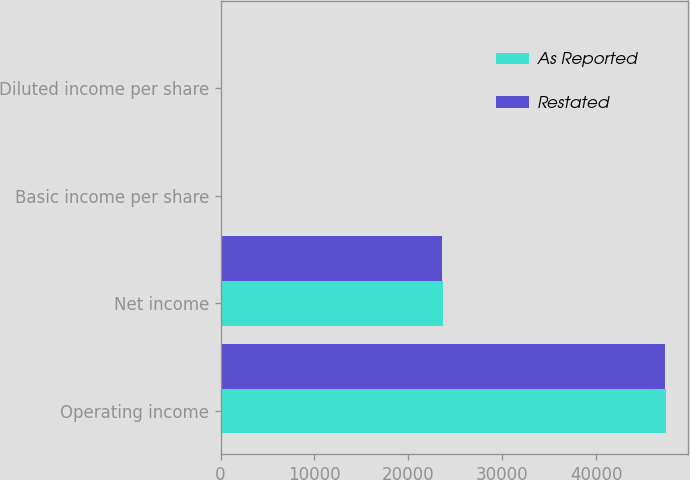<chart> <loc_0><loc_0><loc_500><loc_500><stacked_bar_chart><ecel><fcel>Operating income<fcel>Net income<fcel>Basic income per share<fcel>Diluted income per share<nl><fcel>As Reported<fcel>47461<fcel>23693<fcel>0.26<fcel>0.26<nl><fcel>Restated<fcel>47333<fcel>23589<fcel>0.26<fcel>0.25<nl></chart> 